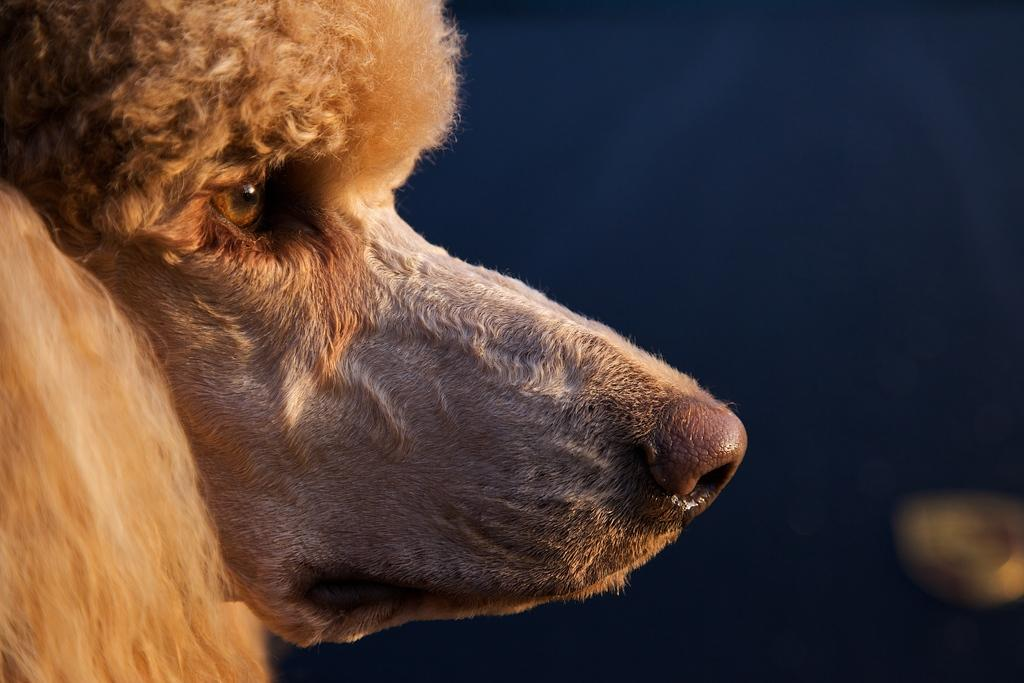What type of animal is present in the image? There is a brown color dog in the image. What type of noise is the dog making in the image? There is no indication of any noise made by the dog in the image. Is there a fire visible in the image? No, there is no fire present in the image. What type of carriage can be seen in the image? There is no carriage present in the image. 